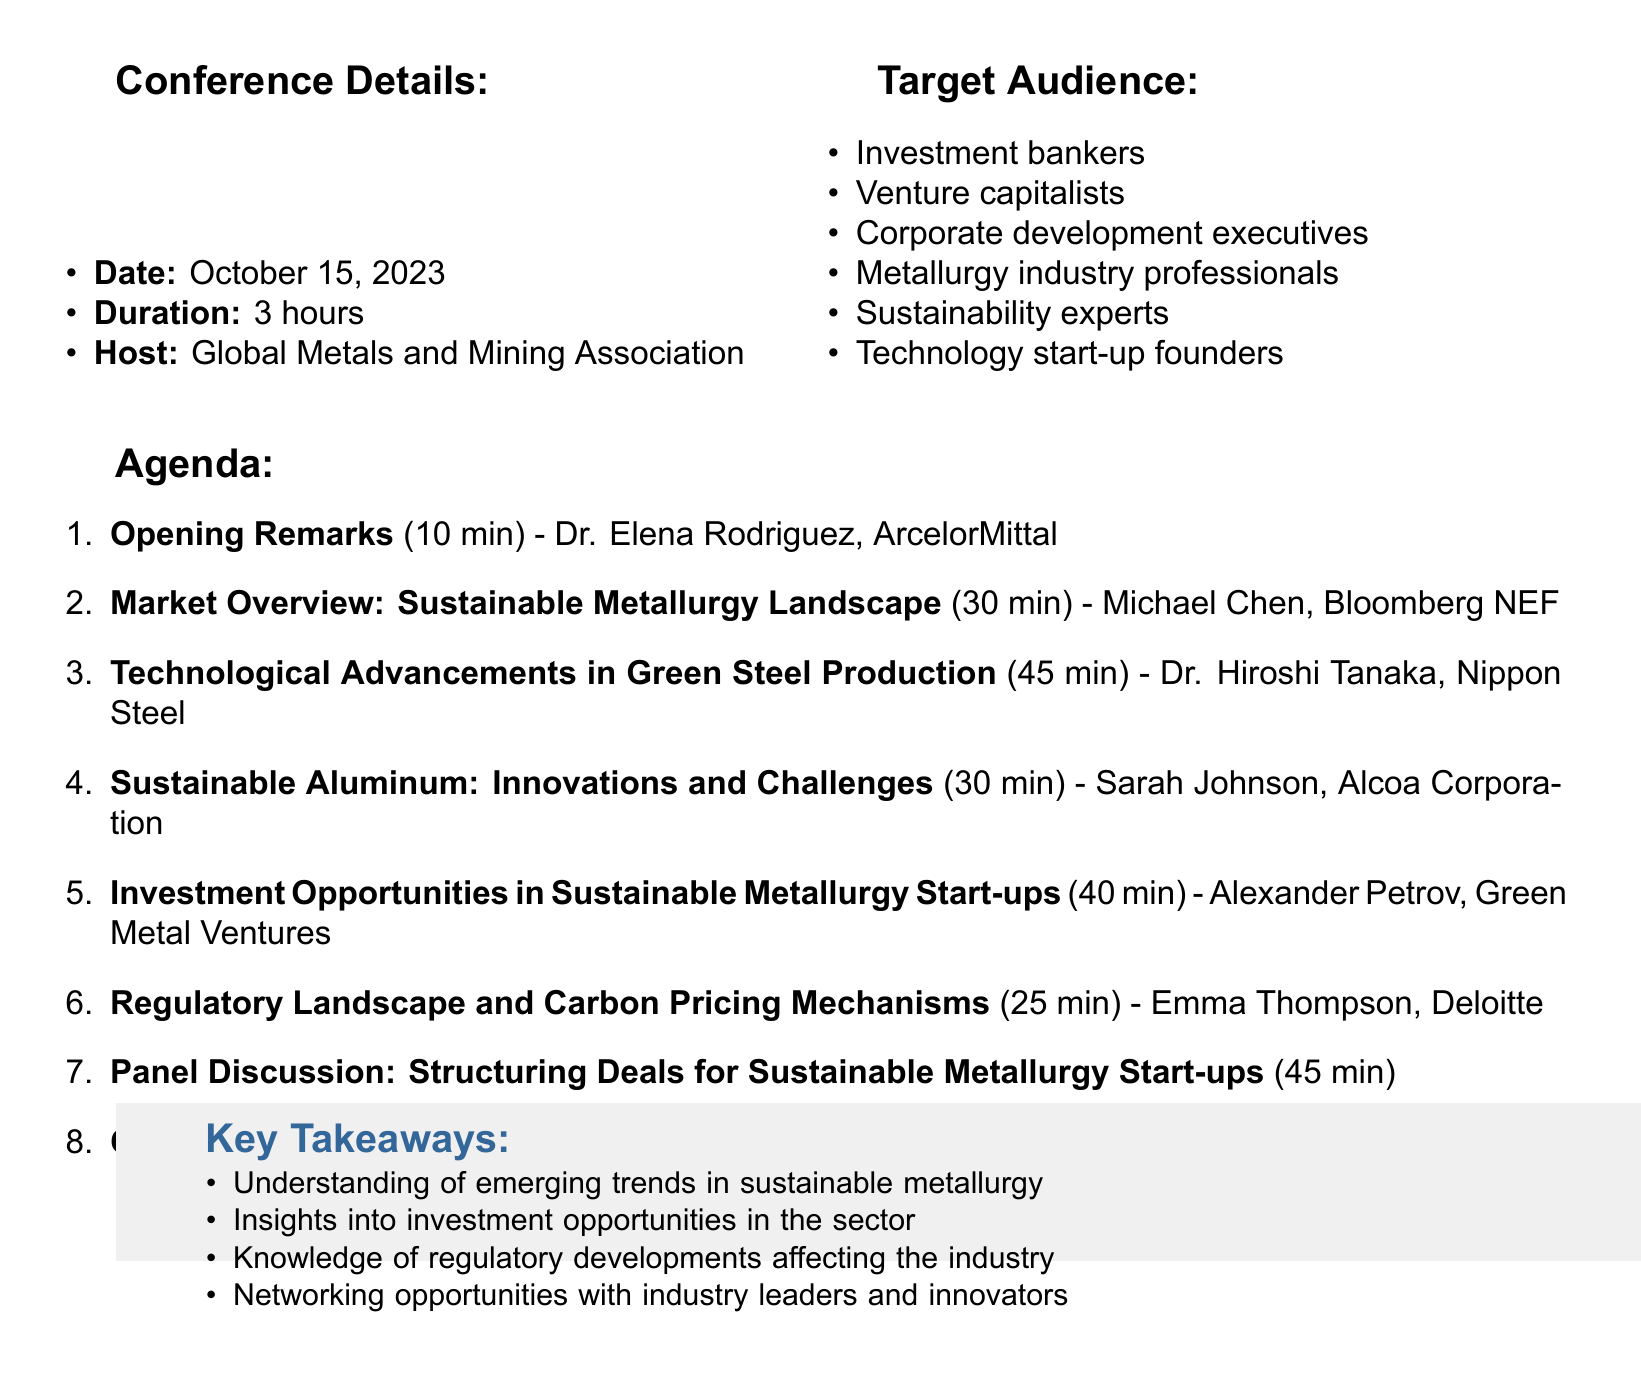What is the title of the conference? The title of the conference is mentioned at the beginning of the document under "conference_title."
Answer: Sustainable Metallurgy: Emerging Trends and Investment Opportunities Who is the speaker for the opening remarks? The document lists the speaker for opening remarks in the first agenda item.
Answer: Dr. Elena Rodriguez How long is the session on "Technological Advancements in Green Steel Production"? This information is found in the duration of the corresponding agenda item.
Answer: 45 minutes What is one key point discussed in the session on Sustainable Aluminum? The key points are listed under the corresponding agenda item.
Answer: Inert anode technology for carbon-free smelting What is the duration of the panel discussion? The duration is specified in the agenda item for the panel discussion.
Answer: 45 minutes Which organization is hosting the conference? This information is found in the section detailing conference details.
Answer: Global Metals and Mining Association What are the target audience categories identified in the document? The audience categories are outlined in the "Target Audience" section.
Answer: Investment bankers, Venture capitalists, Corporate development executives, Metallurgy industry professionals, Sustainability experts, Technology start-up founders What is one of the discussion points for the panel discussion? The discussion points are listed for the panel section in the agenda.
Answer: Valuation methodologies for sustainable metallurgy start-ups What will happen during the closing remarks? The closing remarks are followed by a networking session mentioned in the closing agenda item.
Answer: Networking Session 